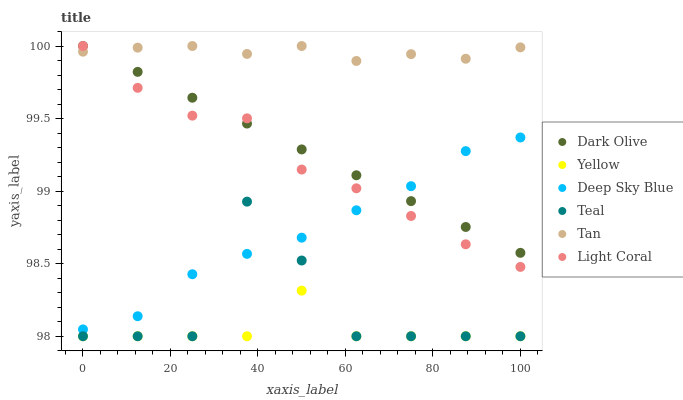Does Yellow have the minimum area under the curve?
Answer yes or no. Yes. Does Tan have the maximum area under the curve?
Answer yes or no. Yes. Does Dark Olive have the minimum area under the curve?
Answer yes or no. No. Does Dark Olive have the maximum area under the curve?
Answer yes or no. No. Is Dark Olive the smoothest?
Answer yes or no. Yes. Is Teal the roughest?
Answer yes or no. Yes. Is Yellow the smoothest?
Answer yes or no. No. Is Yellow the roughest?
Answer yes or no. No. Does Yellow have the lowest value?
Answer yes or no. Yes. Does Dark Olive have the lowest value?
Answer yes or no. No. Does Tan have the highest value?
Answer yes or no. Yes. Does Yellow have the highest value?
Answer yes or no. No. Is Teal less than Light Coral?
Answer yes or no. Yes. Is Tan greater than Yellow?
Answer yes or no. Yes. Does Light Coral intersect Deep Sky Blue?
Answer yes or no. Yes. Is Light Coral less than Deep Sky Blue?
Answer yes or no. No. Is Light Coral greater than Deep Sky Blue?
Answer yes or no. No. Does Teal intersect Light Coral?
Answer yes or no. No. 